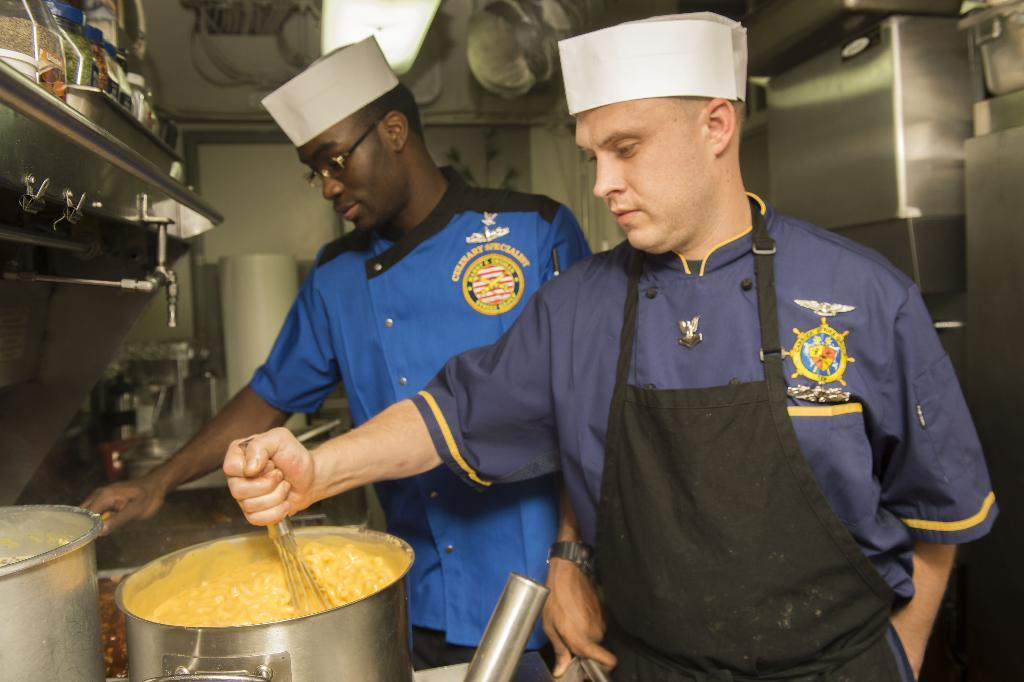What can be seen in the image? There are men standing in the image. What are the men holding in their hands? The men are holding utensils in their hands. What can be seen in the background of the image? Walls, pet jars, and utensils are visible in the background of the image. What request did the men make in the image? There is no indication in the image that the men made any requests. What is the men's shared belief in the image? There is no information about the men's beliefs in the image. 